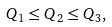<formula> <loc_0><loc_0><loc_500><loc_500>Q _ { 1 } \leq Q _ { 2 } \leq Q _ { 3 } ,</formula> 